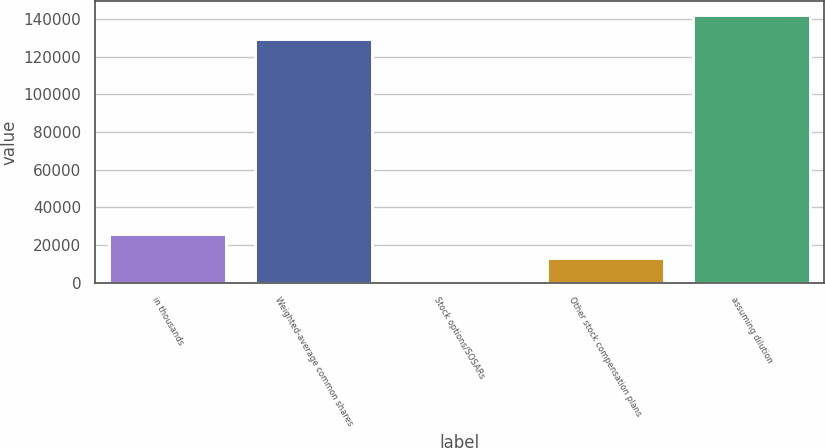Convert chart to OTSL. <chart><loc_0><loc_0><loc_500><loc_500><bar_chart><fcel>in thousands<fcel>Weighted-average common shares<fcel>Stock options/SOSARs<fcel>Other stock compensation plans<fcel>assuming dilution<nl><fcel>25876.5<fcel>129381<fcel>0.31<fcel>12938.4<fcel>142319<nl></chart> 